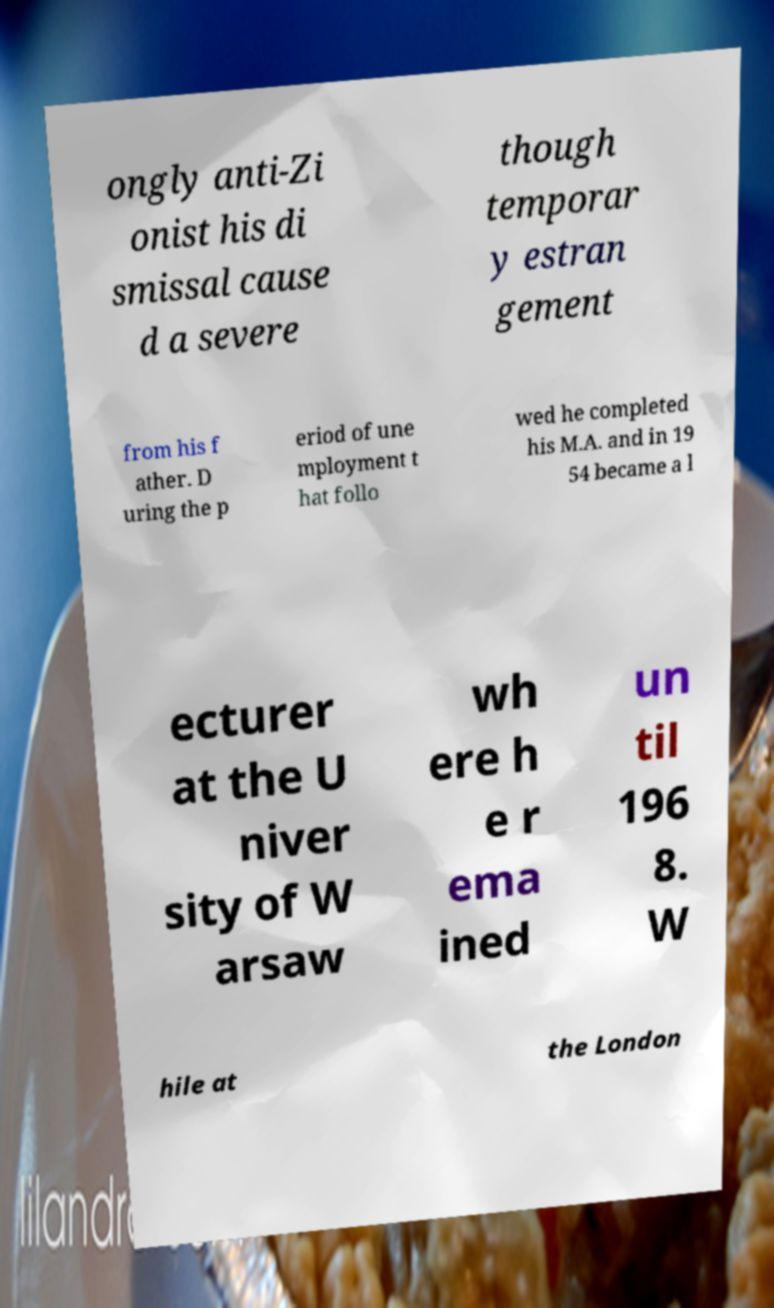Can you accurately transcribe the text from the provided image for me? ongly anti-Zi onist his di smissal cause d a severe though temporar y estran gement from his f ather. D uring the p eriod of une mployment t hat follo wed he completed his M.A. and in 19 54 became a l ecturer at the U niver sity of W arsaw wh ere h e r ema ined un til 196 8. W hile at the London 